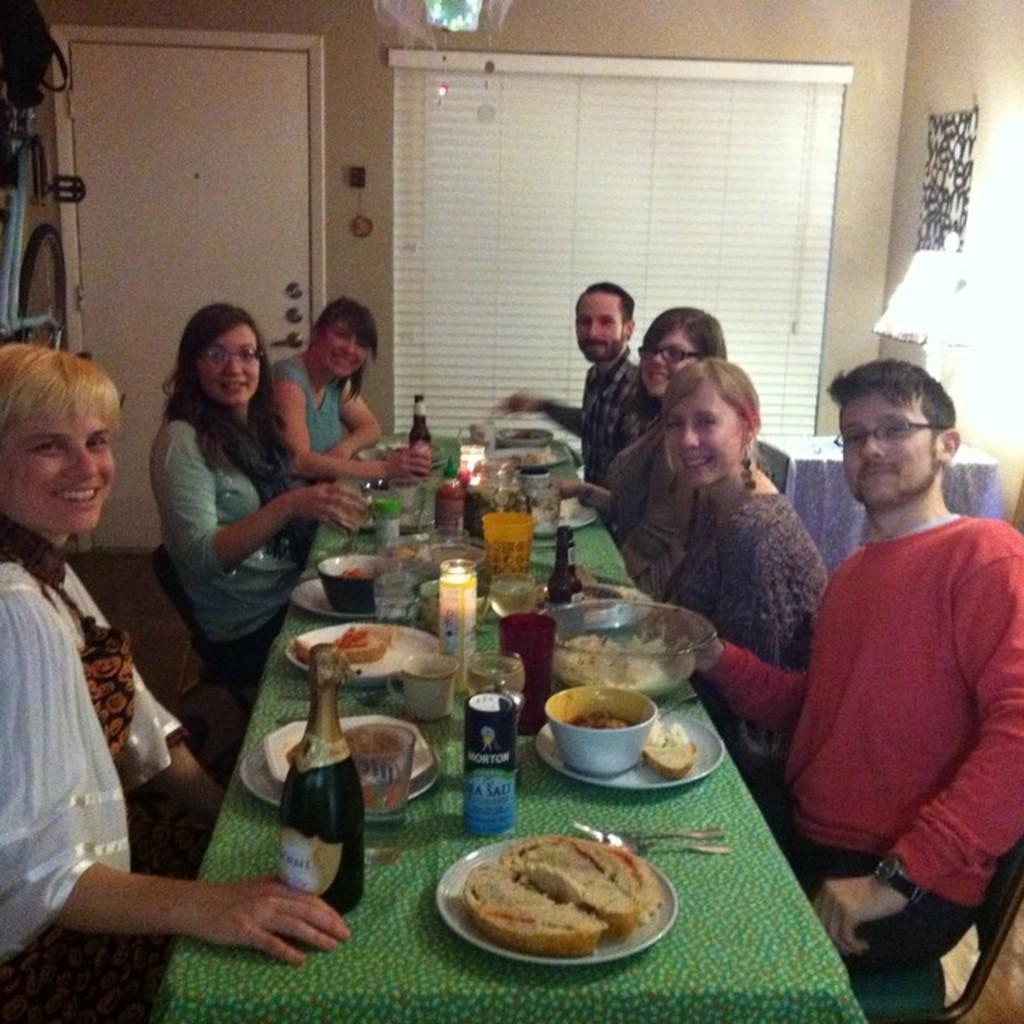Describe this image in one or two sentences. In this picture there are group of people who are sitting on the chair. There is a bottle, bowl, plate, glass and food on the table. There is a dish, fork , spoon on the table. There is a light and a lamp. There is a door. 